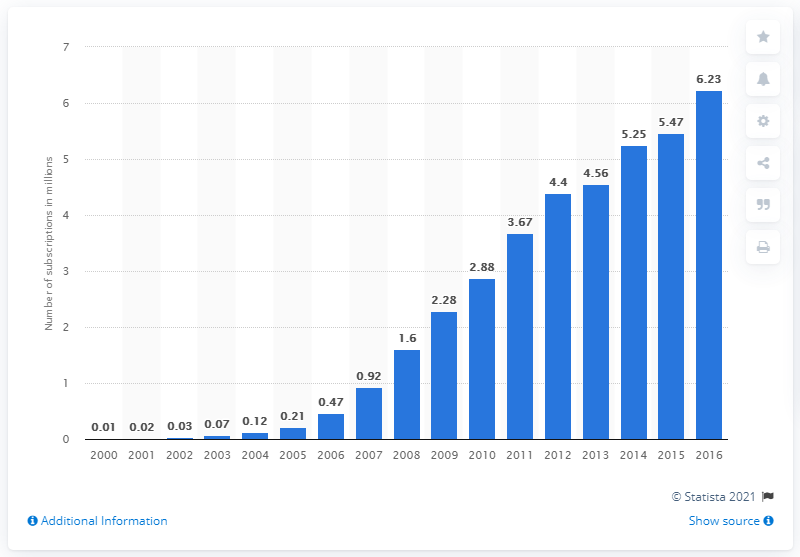Specify some key components in this picture. In 2016, there were approximately 6.23 mobile subscriptions per 100 inhabitants in Chad. 